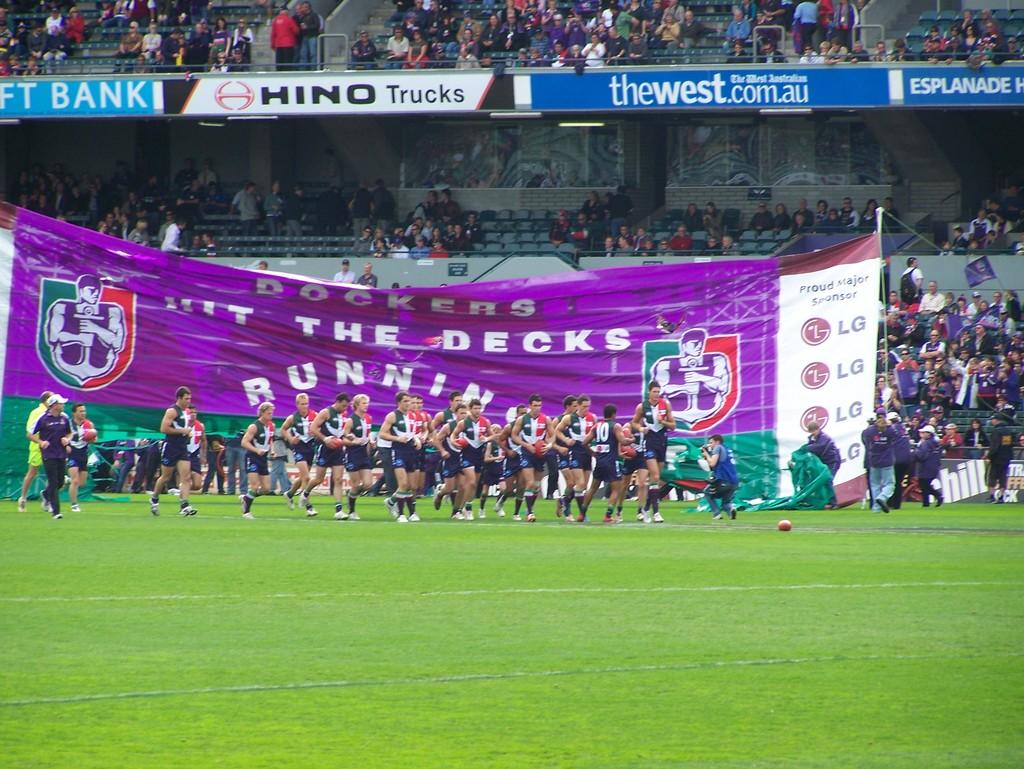Who is to hit the decks running?
Make the answer very short. Dockers. What trucks company is listed?
Give a very brief answer. Hino. 